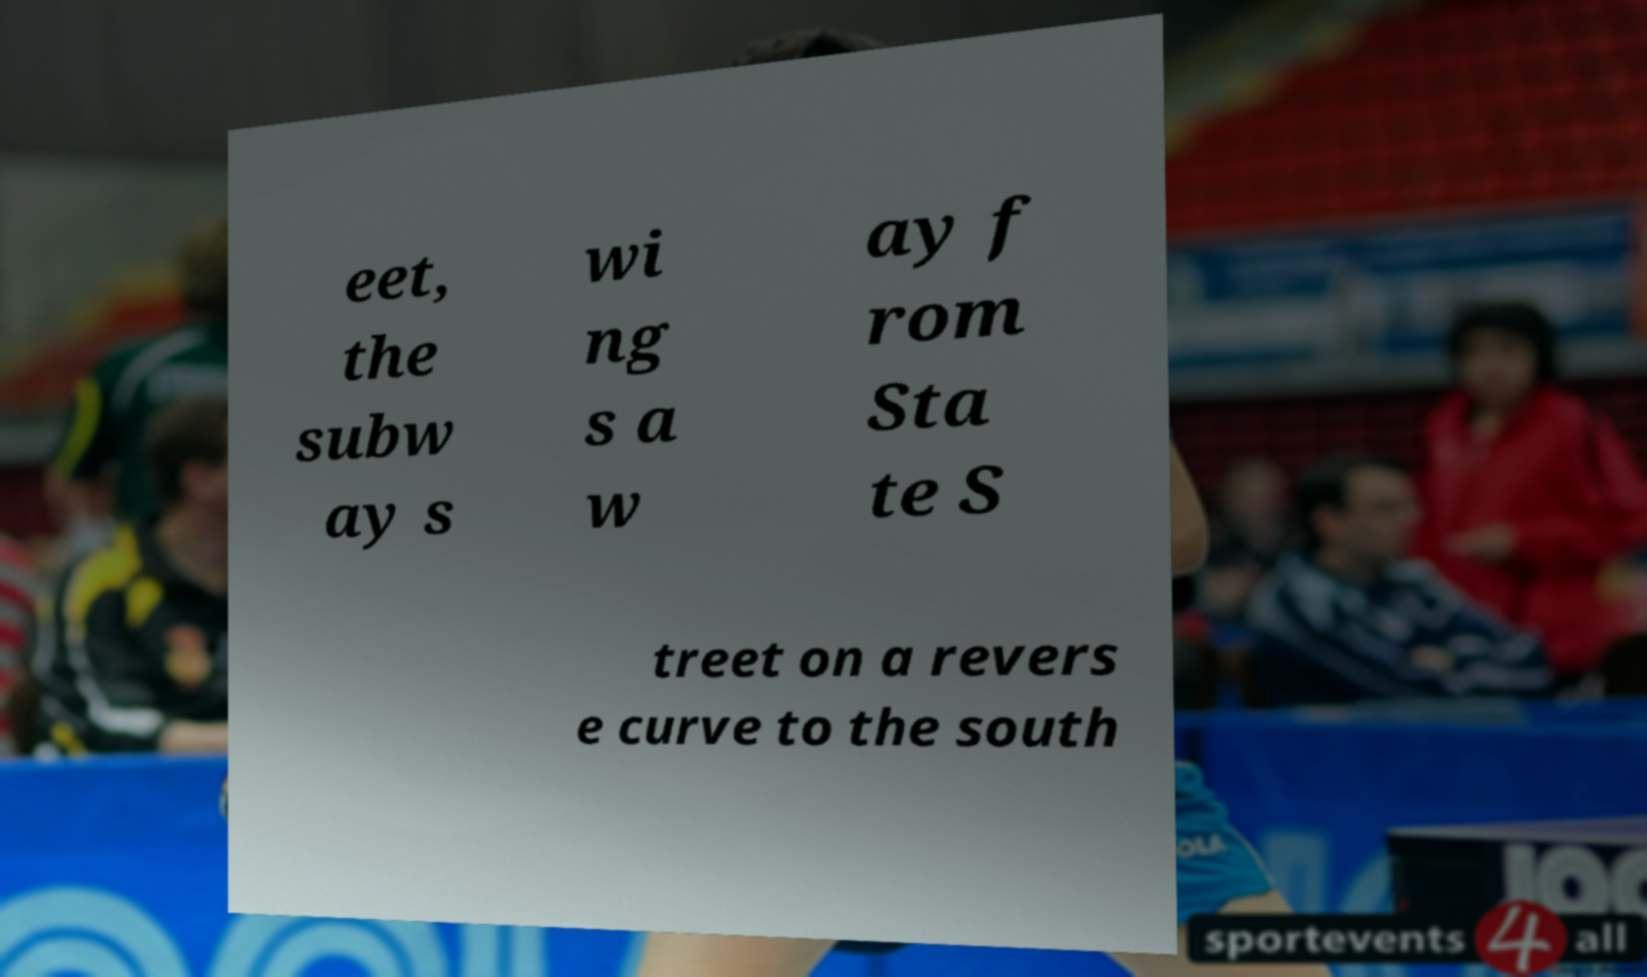For documentation purposes, I need the text within this image transcribed. Could you provide that? eet, the subw ay s wi ng s a w ay f rom Sta te S treet on a revers e curve to the south 